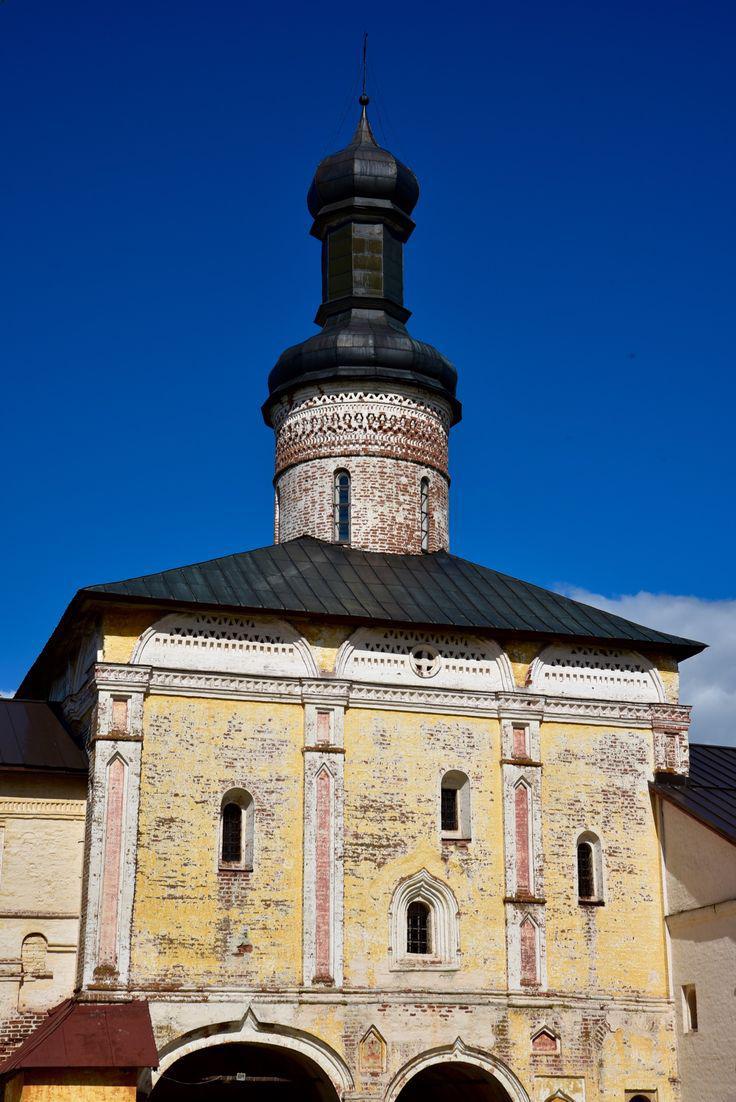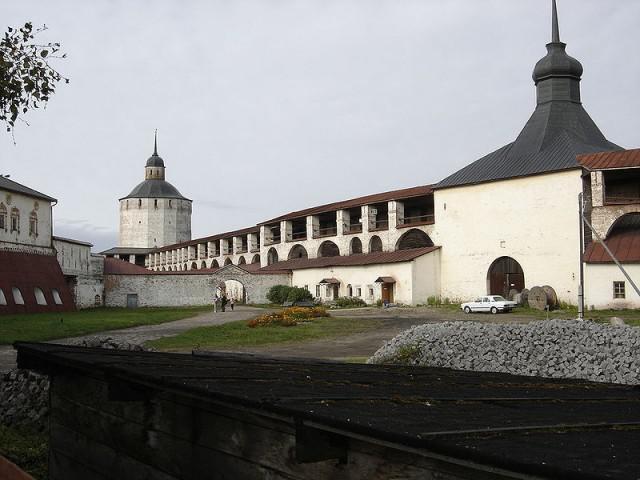The first image is the image on the left, the second image is the image on the right. Given the left and right images, does the statement "There are two steeples in the image on the right." hold true? Answer yes or no. Yes. The first image is the image on the left, the second image is the image on the right. Assess this claim about the two images: "An image shows a building with a tall black-topped tower on top of a black peaked roof, in front of a vivid blue with only a tiny cloud patch visible.". Correct or not? Answer yes or no. Yes. 